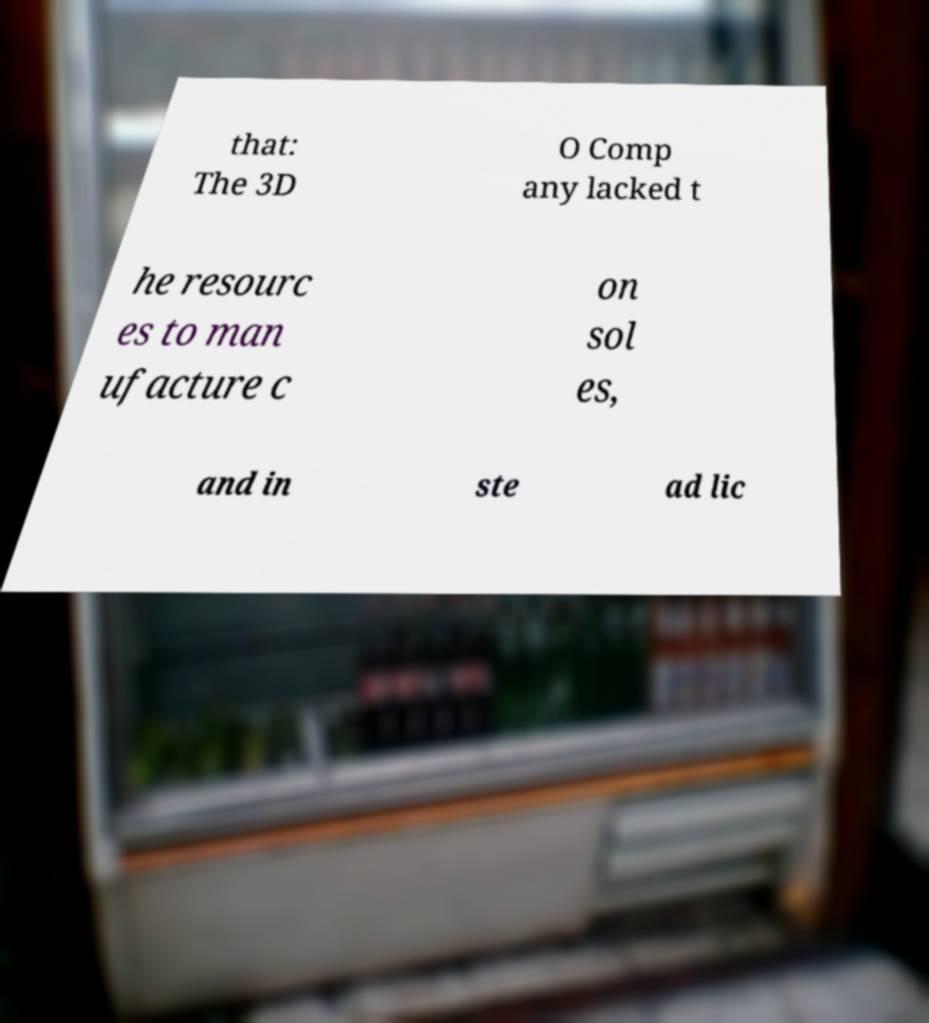For documentation purposes, I need the text within this image transcribed. Could you provide that? that: The 3D O Comp any lacked t he resourc es to man ufacture c on sol es, and in ste ad lic 